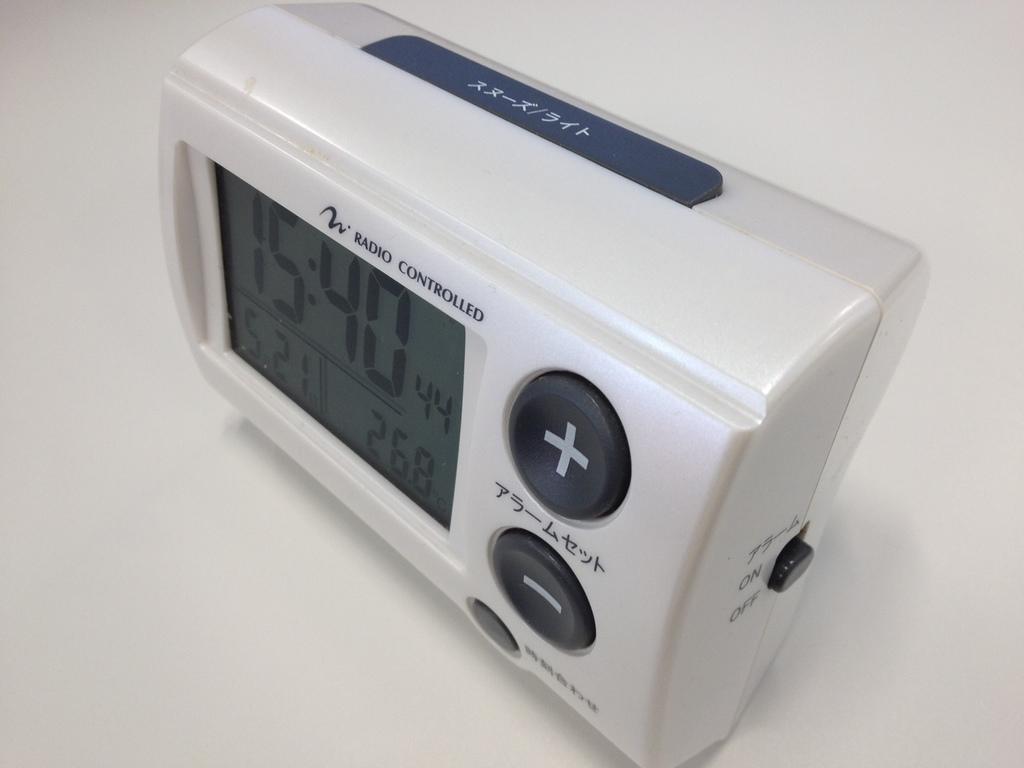What tiem is it?
Your answer should be compact. 15:40. 